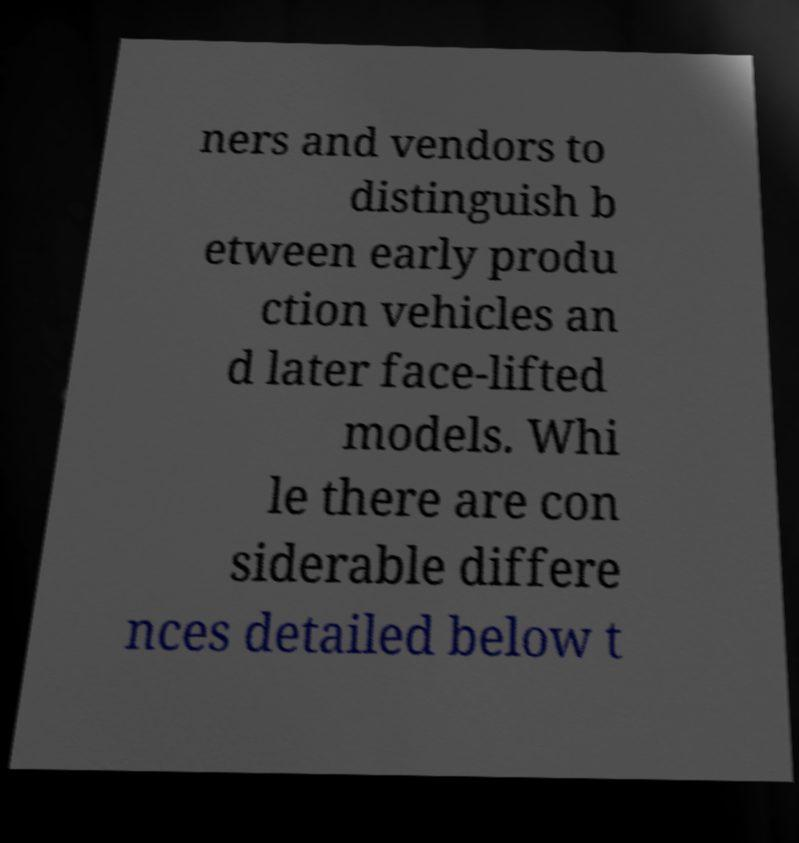Can you accurately transcribe the text from the provided image for me? ners and vendors to distinguish b etween early produ ction vehicles an d later face-lifted models. Whi le there are con siderable differe nces detailed below t 